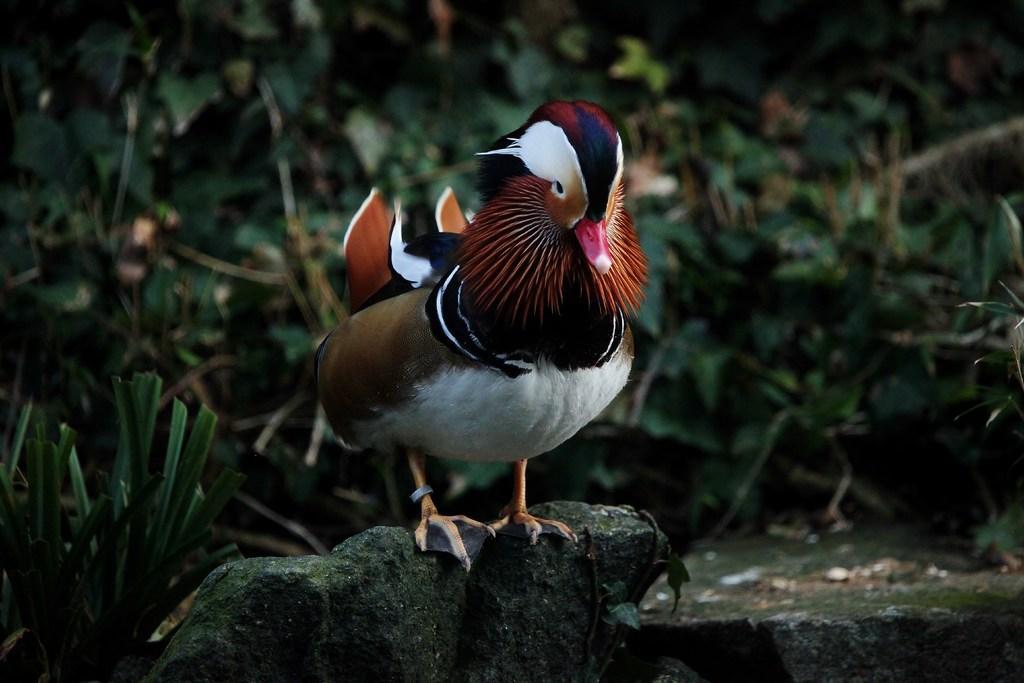In one or two sentences, can you explain what this image depicts? In this picture we can see a bird standing on a rock and in the background we can see leaves. 